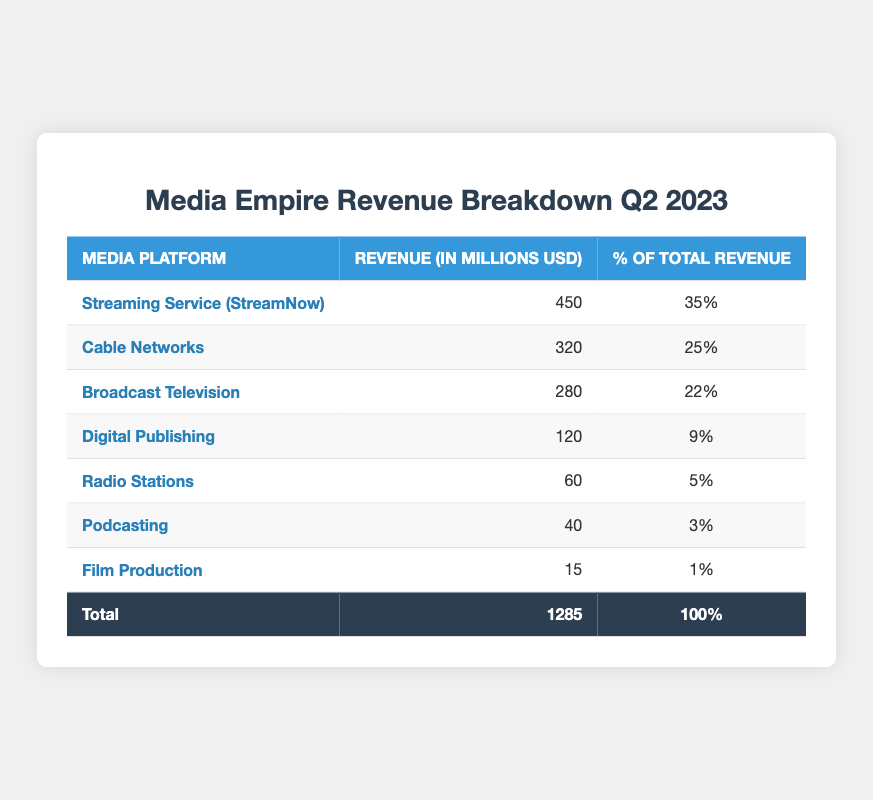What is the revenue generated by Streaming Service (StreamNow)? The table shows that the revenue for Streaming Service (StreamNow) is listed under the "Revenue (in millions USD)" column, which shows a value of 450.
Answer: 450 What percentage of total revenue does Cable Networks represent? The percentage of total revenue for Cable Networks is displayed in the "% of Total Revenue" column, which indicates a value of 25%.
Answer: 25% Is the revenue from Podcasting greater than that from Film Production? The revenue for Podcasting is 40 million USD, while for Film Production it is 15 million USD. Since 40 > 15, the revenue from Podcasting is indeed greater.
Answer: Yes What is the total revenue from the top three media platforms? The top three media platforms in terms of revenue are Streaming Service (StreamNow) with 450 million, Cable Networks with 320 million, and Broadcast Television with 280 million. Adding these values gives 450 + 320 + 280 = 1050 million.
Answer: 1050 What is the revenue from Digital Publishing compared to the total revenue? The revenue from Digital Publishing is 120 million USD. The total revenue is 1285 million USD. To find the comparison, we can say that Digital Publishing revenue is a fraction of the total: 120/1285, which indicates it is relatively smaller.
Answer: 120 million (smaller than total revenue) What is the percentage of total revenue from the bottom two media platforms (Podcasting and Film Production)? The percentage of total revenue for Podcasting is 3% and for Film Production is 1%. Adding these gives 3% + 1% = 4%.
Answer: 4% Is Broadcast Television responsible for more than 20% of the total revenue? The "% of Total Revenue" column shows Broadcast Television at 22%. Since 22% is greater than 20%, it is indeed responsible for more.
Answer: Yes What is the difference in revenue between the highest and lowest media platforms? The highest media platform is Streaming Service (StreamNow) with 450 million and the lowest is Film Production with 15 million. Calculating the difference gives us: 450 - 15 = 435 million.
Answer: 435 million 